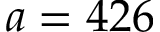Convert formula to latex. <formula><loc_0><loc_0><loc_500><loc_500>a = 4 2 6</formula> 